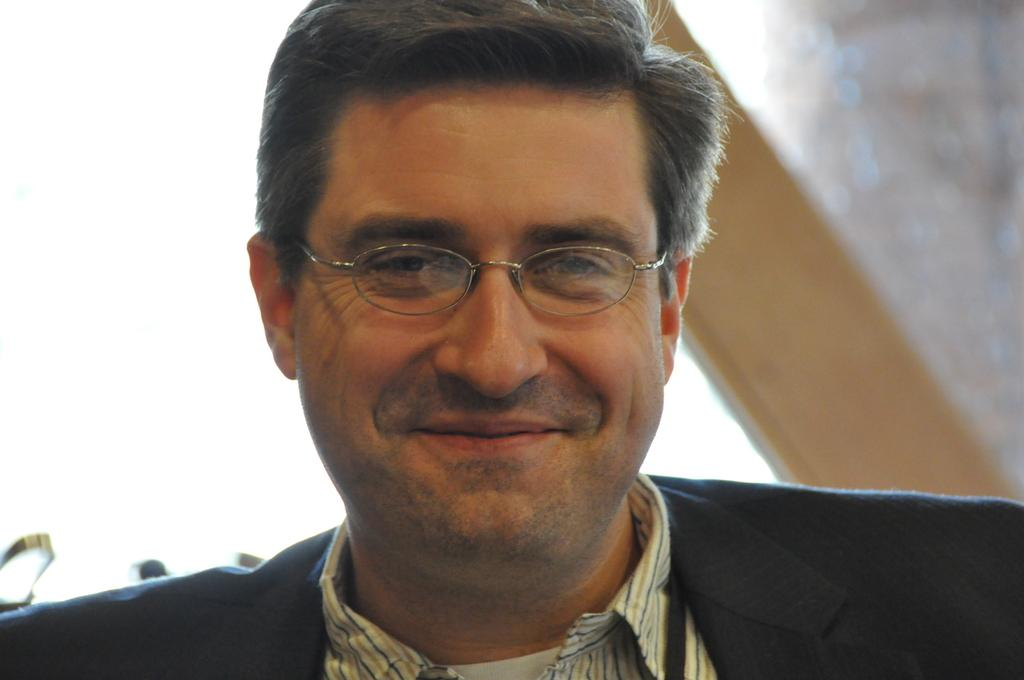Who is present in the image? There is a man in the picture. What is the man's facial expression? The man is smiling. What type of clothing is the man wearing? The man is wearing a shirt and a suit. What accessory is the man wearing on his face? The man has spectacles on his eyes. What type of honey is the man holding in the image? There is no honey present in the image; the man is not holding anything. 